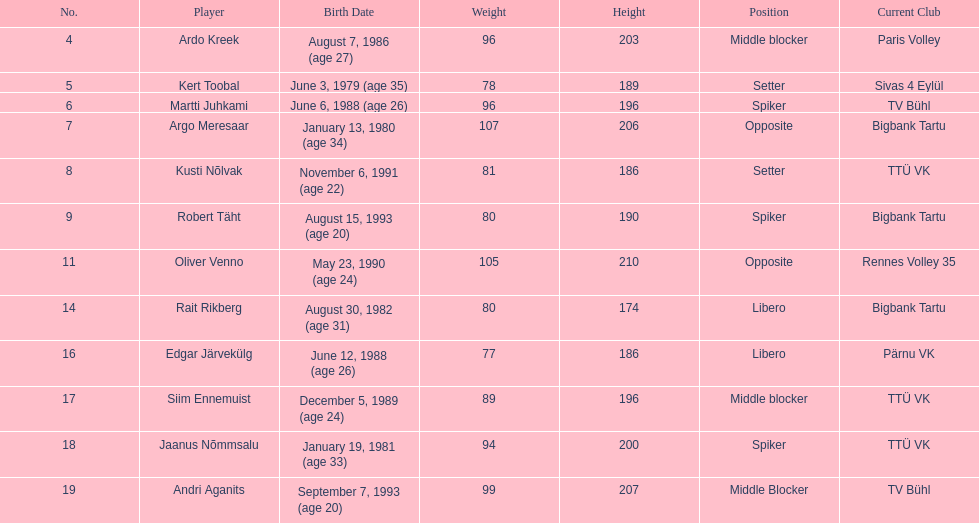What is the count of players with a birthdate before 1988? 5. 